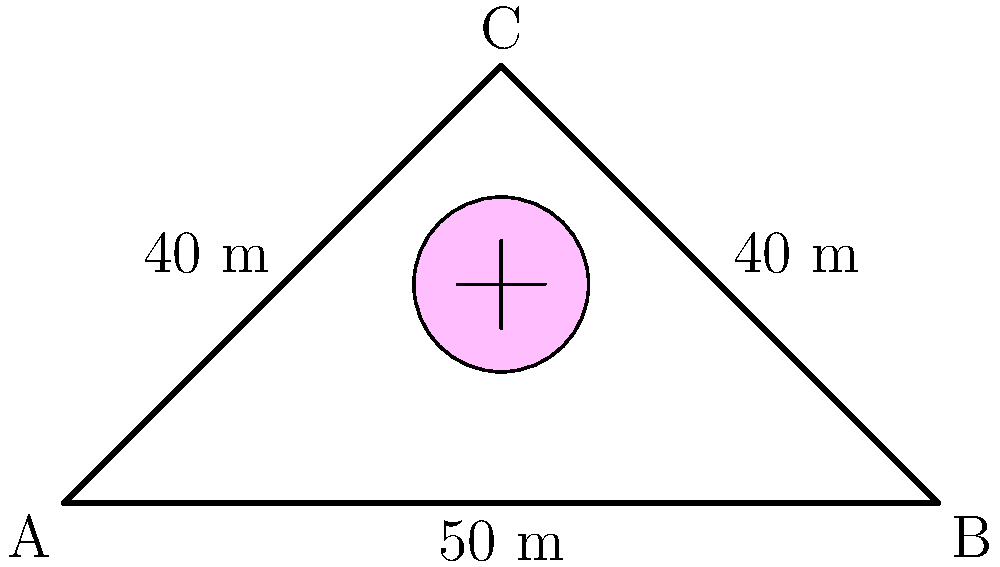Design a Jeffree Star-inspired bridge truss system with the given dimensions. If the maximum allowable stress in any member is 200 MPa and the cross-sectional area of each member is 0.005 m², what is the maximum load (in kN) that can be applied at point C without exceeding the allowable stress? To solve this problem, we'll follow these fabulous Jeffree Star-worthy steps:

1. Identify the truss system:
   - It's a simple triangular truss with members AB, BC, and AC.
   - The truss is symmetrical, which is as balanced as Jeffree's makeup looks!

2. Calculate the angle θ between the horizontal and the inclined members:
   $$\theta = \tan^{-1}(\frac{50}{50}) = 45°$$

3. Determine the forces in the members using method of joints at C:
   - Let P be the applied load at C
   - For equilibrium in the vertical direction:
     $$P = 2F_{AC}\sin(45°)$$
   - Force in AC (and BC due to symmetry):
     $$F_{AC} = F_{BC} = \frac{P}{2\sin(45°)} = \frac{P}{1.414}$$

4. Calculate the maximum allowable force in any member:
   $$F_{max} = \sigma_{max} \times A = 200 \times 10^6 \times 0.005 = 1,000,000 N = 1000 kN$$

5. Set the force in AC equal to the maximum allowable force and solve for P:
   $$1000 = \frac{P}{1.414}$$
   $$P = 1000 \times 1.414 = 1414 kN$$

This stunning result is as impressive as Jeffree's makeup collection!
Answer: 1414 kN 